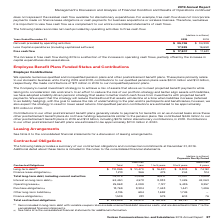According to Verizon Communications's financial document, What was the total long-term debt? According to the financial document, $110,865 (in millions). The relevant text states: "Long-term debt (1) $ 110,865 $ 10,470 $ 16,431 $ 9,803 $ 74,161..." Also, What was the long-term debt less than 1 year? According to the financial document, $ 10,470 (in millions). The relevant text states: "Long-term debt (1) $ 110,865 $ 10,470 $ 16,431 $ 9,803 $ 74,161..." Also, What was the total finance lease obligation? According to the financial document, 1,213 (in millions). The relevant text states: "Finance lease obligations (2) 1,213 366 479 244 124..." Also, can you calculate: What is the difference between the long-term debt due less than 1 year and 1 to 3 years? Based on the calculation: 16,431 - 10,470, the result is 5961 (in millions). This is based on the information: "Long-term debt (1) $ 110,865 $ 10,470 $ 16,431 $ 9,803 $ 74,161 Long-term debt (1) $ 110,865 $ 10,470 $ 16,431 $ 9,803 $ 74,161..." The key data points involved are: 10,470, 16,431. Also, can you calculate: What is the average long term debt payment for each payment period? To answer this question, I need to perform calculations using the financial data. The calculation is: (10,470 + 16,431 + 9,803 + 74,161) / 4, which equals 27716.25 (in millions). This is based on the information: "rm debt (1) $ 110,865 $ 10,470 $ 16,431 $ 9,803 $ 74,161 Long-term debt (1) $ 110,865 $ 10,470 $ 16,431 $ 9,803 $ 74,161 Long-term debt (1) $ 110,865 $ 10,470 $ 16,431 $ 9,803 $ 74,161 Long-term debt ..." The key data points involved are: 10,470, 16,431, 74,161. Also, can you calculate: What is the average finance lease obligation for each payment period? To answer this question, I need to perform calculations using the financial data. The calculation is: (366 + 479 + 244 + 124) / 4, which equals 303.25 (in millions). This is based on the information: "Finance lease obligations (2) 1,213 366 479 244 124 Finance lease obligations (2) 1,213 366 479 244 124 Finance lease obligations (2) 1,213 366 479 244 124 Finance lease obligations (2) 1,213 366 479 ..." The key data points involved are: 124, 244, 366. 